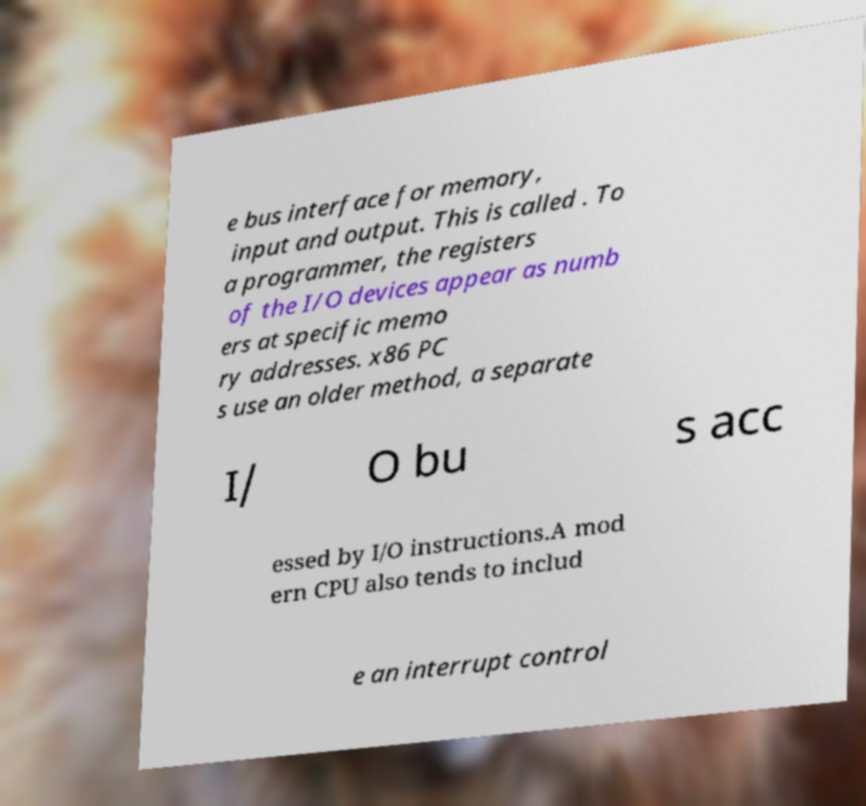For documentation purposes, I need the text within this image transcribed. Could you provide that? e bus interface for memory, input and output. This is called . To a programmer, the registers of the I/O devices appear as numb ers at specific memo ry addresses. x86 PC s use an older method, a separate I/ O bu s acc essed by I/O instructions.A mod ern CPU also tends to includ e an interrupt control 